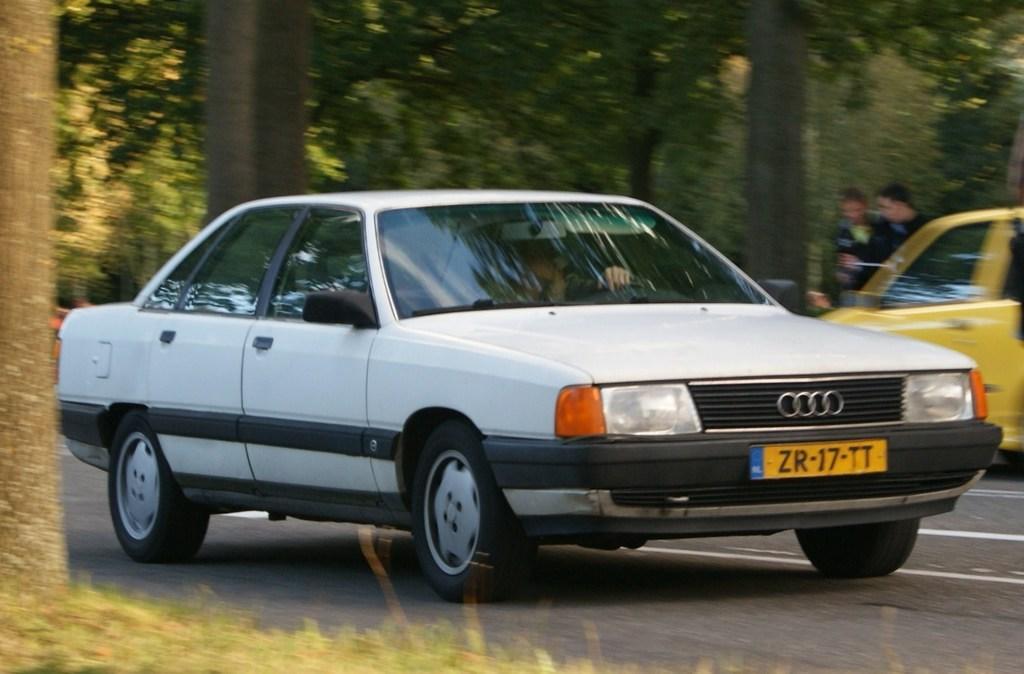Can you describe this image briefly? There is a road. On the road there are vehicles. On the sides of the road there are trees. In the back there are two people. 